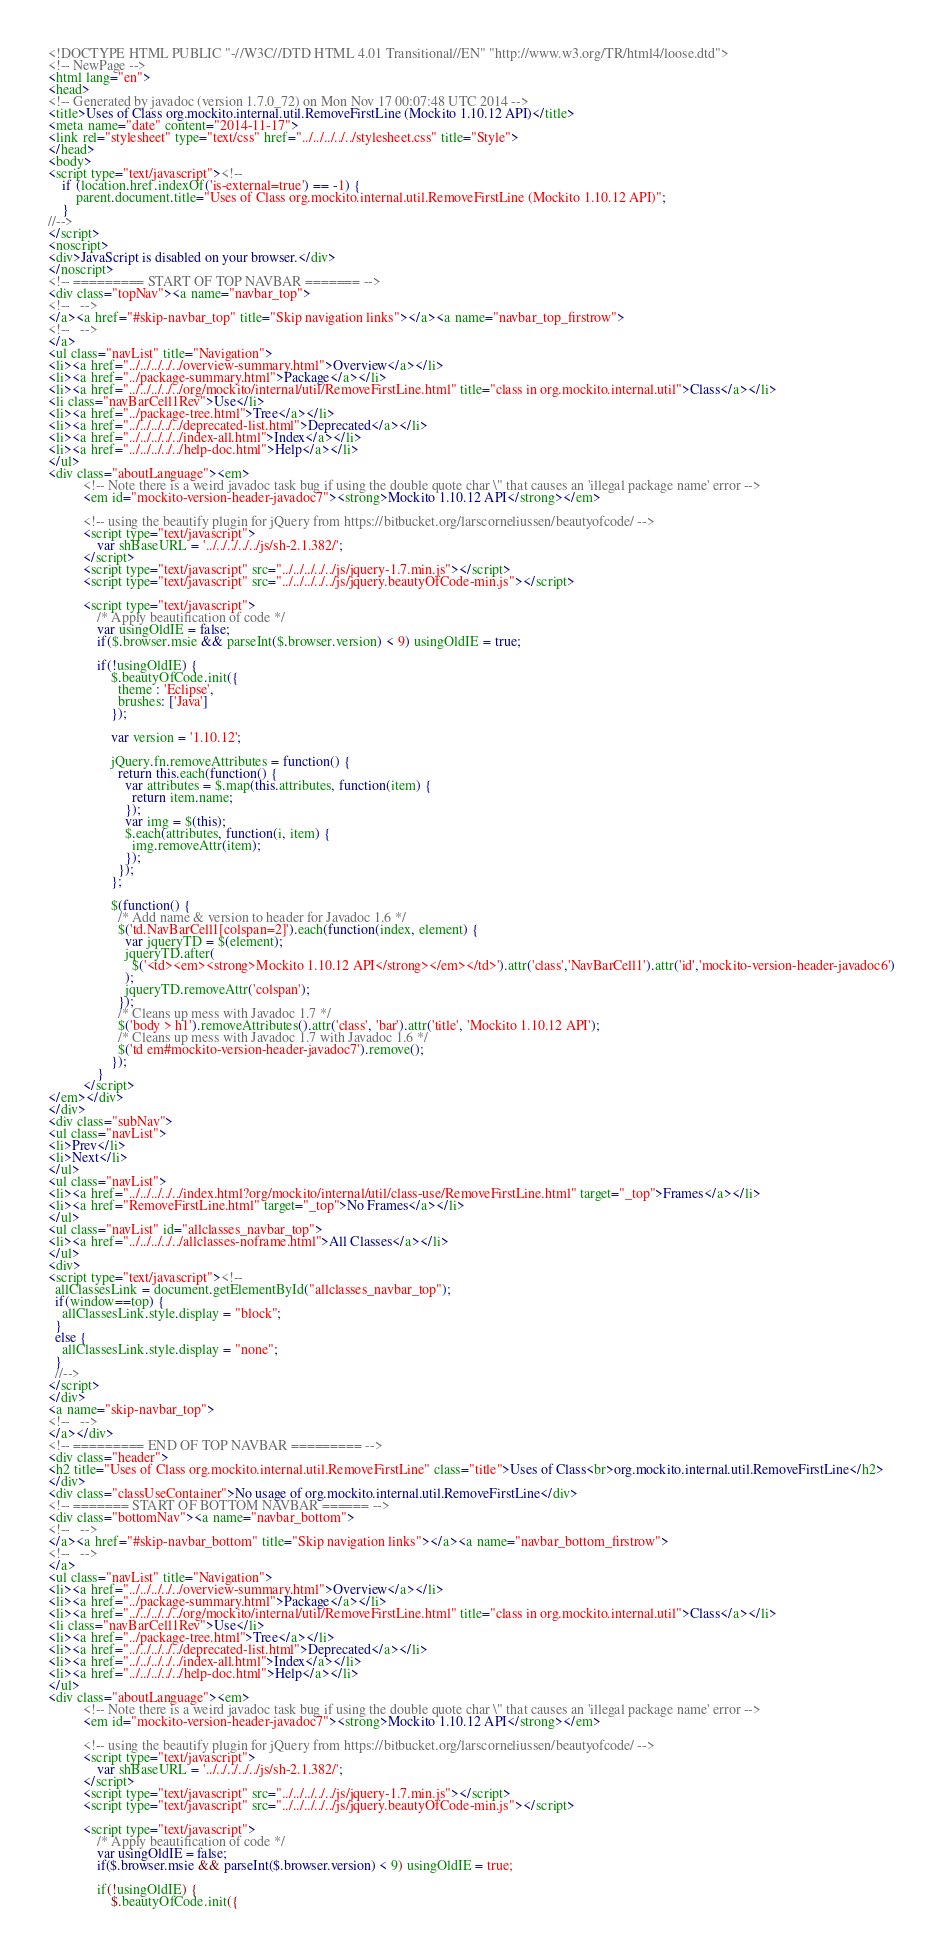<code> <loc_0><loc_0><loc_500><loc_500><_HTML_><!DOCTYPE HTML PUBLIC "-//W3C//DTD HTML 4.01 Transitional//EN" "http://www.w3.org/TR/html4/loose.dtd">
<!-- NewPage -->
<html lang="en">
<head>
<!-- Generated by javadoc (version 1.7.0_72) on Mon Nov 17 00:07:48 UTC 2014 -->
<title>Uses of Class org.mockito.internal.util.RemoveFirstLine (Mockito 1.10.12 API)</title>
<meta name="date" content="2014-11-17">
<link rel="stylesheet" type="text/css" href="../../../../../stylesheet.css" title="Style">
</head>
<body>
<script type="text/javascript"><!--
    if (location.href.indexOf('is-external=true') == -1) {
        parent.document.title="Uses of Class org.mockito.internal.util.RemoveFirstLine (Mockito 1.10.12 API)";
    }
//-->
</script>
<noscript>
<div>JavaScript is disabled on your browser.</div>
</noscript>
<!-- ========= START OF TOP NAVBAR ======= -->
<div class="topNav"><a name="navbar_top">
<!--   -->
</a><a href="#skip-navbar_top" title="Skip navigation links"></a><a name="navbar_top_firstrow">
<!--   -->
</a>
<ul class="navList" title="Navigation">
<li><a href="../../../../../overview-summary.html">Overview</a></li>
<li><a href="../package-summary.html">Package</a></li>
<li><a href="../../../../../org/mockito/internal/util/RemoveFirstLine.html" title="class in org.mockito.internal.util">Class</a></li>
<li class="navBarCell1Rev">Use</li>
<li><a href="../package-tree.html">Tree</a></li>
<li><a href="../../../../../deprecated-list.html">Deprecated</a></li>
<li><a href="../../../../../index-all.html">Index</a></li>
<li><a href="../../../../../help-doc.html">Help</a></li>
</ul>
<div class="aboutLanguage"><em>
          <!-- Note there is a weird javadoc task bug if using the double quote char \" that causes an 'illegal package name' error -->
          <em id="mockito-version-header-javadoc7"><strong>Mockito 1.10.12 API</strong></em>

          <!-- using the beautify plugin for jQuery from https://bitbucket.org/larscorneliussen/beautyofcode/ -->
          <script type="text/javascript">
              var shBaseURL = '../../../../../js/sh-2.1.382/';
          </script>
          <script type="text/javascript" src="../../../../../js/jquery-1.7.min.js"></script>
          <script type="text/javascript" src="../../../../../js/jquery.beautyOfCode-min.js"></script>

          <script type="text/javascript">
              /* Apply beautification of code */
              var usingOldIE = false;
              if($.browser.msie && parseInt($.browser.version) < 9) usingOldIE = true;

              if(!usingOldIE) {
                  $.beautyOfCode.init({
                    theme : 'Eclipse',
                    brushes: ['Java']
                  });

                  var version = '1.10.12';

                  jQuery.fn.removeAttributes = function() {
                    return this.each(function() {
                      var attributes = $.map(this.attributes, function(item) {
                        return item.name;
                      });
                      var img = $(this);
                      $.each(attributes, function(i, item) {
                        img.removeAttr(item);
                      });
                    });
                  };

                  $(function() {
                    /* Add name & version to header for Javadoc 1.6 */
                    $('td.NavBarCell1[colspan=2]').each(function(index, element) {
                      var jqueryTD = $(element);
                      jqueryTD.after(
                        $('<td><em><strong>Mockito 1.10.12 API</strong></em></td>').attr('class','NavBarCell1').attr('id','mockito-version-header-javadoc6')
                      );
                      jqueryTD.removeAttr('colspan');
                    });
                    /* Cleans up mess with Javadoc 1.7 */
                    $('body > h1').removeAttributes().attr('class', 'bar').attr('title', 'Mockito 1.10.12 API');
                    /* Cleans up mess with Javadoc 1.7 with Javadoc 1.6 */
                    $('td em#mockito-version-header-javadoc7').remove();
                  });
              }
          </script>
</em></div>
</div>
<div class="subNav">
<ul class="navList">
<li>Prev</li>
<li>Next</li>
</ul>
<ul class="navList">
<li><a href="../../../../../index.html?org/mockito/internal/util/class-use/RemoveFirstLine.html" target="_top">Frames</a></li>
<li><a href="RemoveFirstLine.html" target="_top">No Frames</a></li>
</ul>
<ul class="navList" id="allclasses_navbar_top">
<li><a href="../../../../../allclasses-noframe.html">All Classes</a></li>
</ul>
<div>
<script type="text/javascript"><!--
  allClassesLink = document.getElementById("allclasses_navbar_top");
  if(window==top) {
    allClassesLink.style.display = "block";
  }
  else {
    allClassesLink.style.display = "none";
  }
  //-->
</script>
</div>
<a name="skip-navbar_top">
<!--   -->
</a></div>
<!-- ========= END OF TOP NAVBAR ========= -->
<div class="header">
<h2 title="Uses of Class org.mockito.internal.util.RemoveFirstLine" class="title">Uses of Class<br>org.mockito.internal.util.RemoveFirstLine</h2>
</div>
<div class="classUseContainer">No usage of org.mockito.internal.util.RemoveFirstLine</div>
<!-- ======= START OF BOTTOM NAVBAR ====== -->
<div class="bottomNav"><a name="navbar_bottom">
<!--   -->
</a><a href="#skip-navbar_bottom" title="Skip navigation links"></a><a name="navbar_bottom_firstrow">
<!--   -->
</a>
<ul class="navList" title="Navigation">
<li><a href="../../../../../overview-summary.html">Overview</a></li>
<li><a href="../package-summary.html">Package</a></li>
<li><a href="../../../../../org/mockito/internal/util/RemoveFirstLine.html" title="class in org.mockito.internal.util">Class</a></li>
<li class="navBarCell1Rev">Use</li>
<li><a href="../package-tree.html">Tree</a></li>
<li><a href="../../../../../deprecated-list.html">Deprecated</a></li>
<li><a href="../../../../../index-all.html">Index</a></li>
<li><a href="../../../../../help-doc.html">Help</a></li>
</ul>
<div class="aboutLanguage"><em>
          <!-- Note there is a weird javadoc task bug if using the double quote char \" that causes an 'illegal package name' error -->
          <em id="mockito-version-header-javadoc7"><strong>Mockito 1.10.12 API</strong></em>

          <!-- using the beautify plugin for jQuery from https://bitbucket.org/larscorneliussen/beautyofcode/ -->
          <script type="text/javascript">
              var shBaseURL = '../../../../../js/sh-2.1.382/';
          </script>
          <script type="text/javascript" src="../../../../../js/jquery-1.7.min.js"></script>
          <script type="text/javascript" src="../../../../../js/jquery.beautyOfCode-min.js"></script>

          <script type="text/javascript">
              /* Apply beautification of code */
              var usingOldIE = false;
              if($.browser.msie && parseInt($.browser.version) < 9) usingOldIE = true;

              if(!usingOldIE) {
                  $.beautyOfCode.init({</code> 